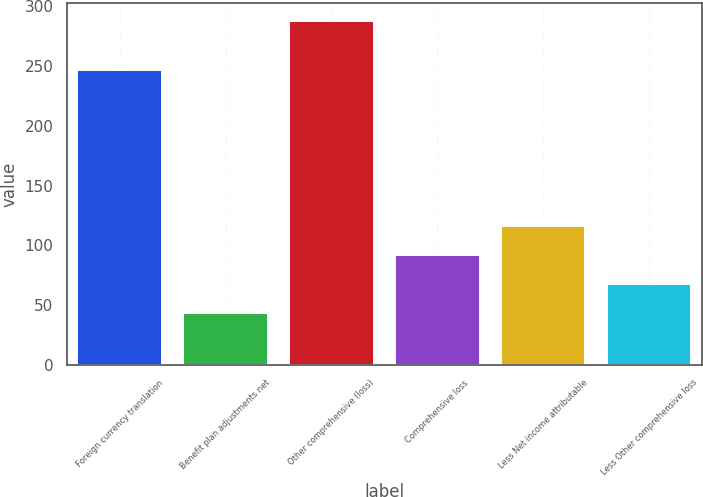Convert chart to OTSL. <chart><loc_0><loc_0><loc_500><loc_500><bar_chart><fcel>Foreign currency translation<fcel>Benefit plan adjustments net<fcel>Other comprehensive (loss)<fcel>Comprehensive loss<fcel>Less Net income attributable<fcel>Less Other comprehensive loss<nl><fcel>247<fcel>43<fcel>288<fcel>92<fcel>116.5<fcel>67.5<nl></chart> 